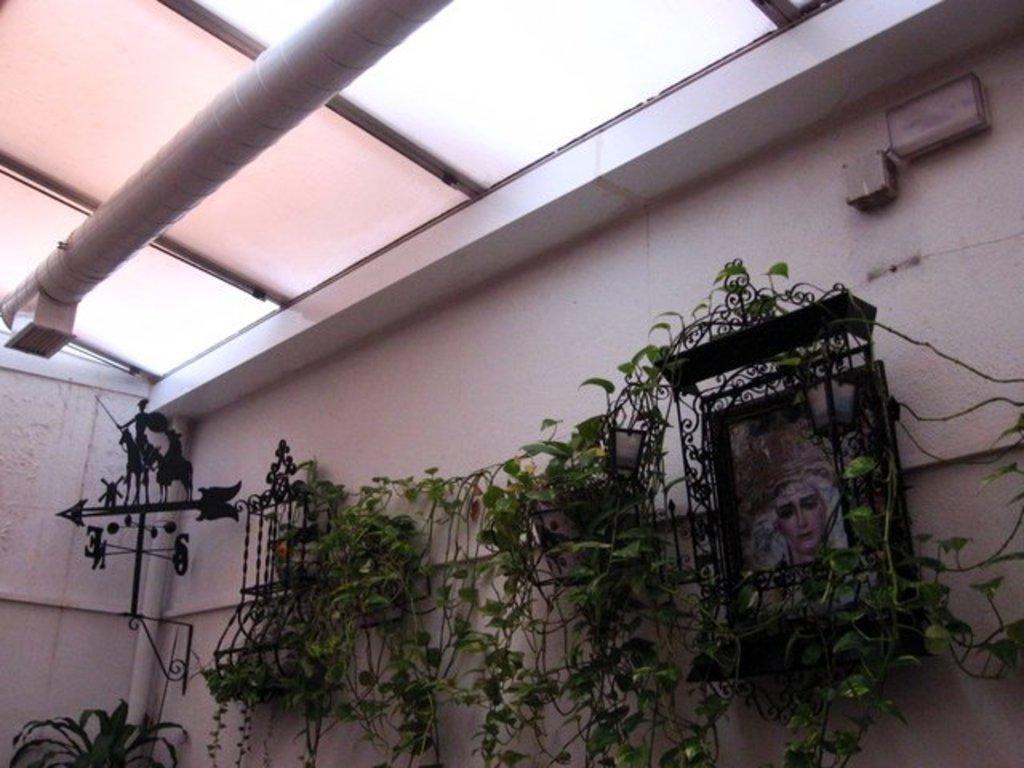How would you summarize this image in a sentence or two? In the image we can see some plants. Behind them there wall, on the wall there are some frames. At the top of the image there is ceiling and pipe. 